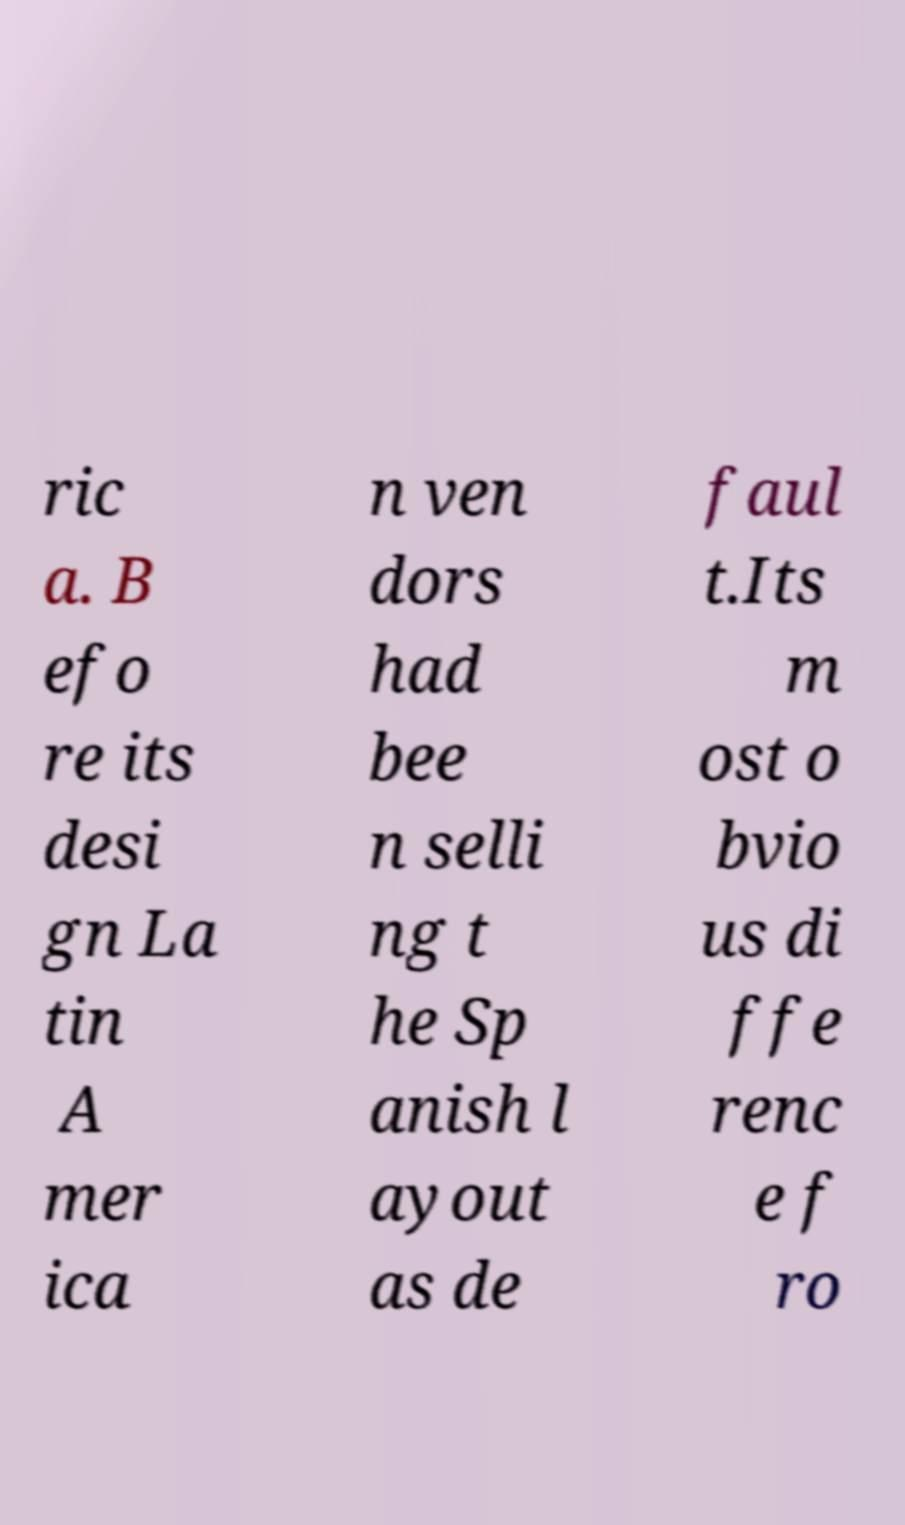There's text embedded in this image that I need extracted. Can you transcribe it verbatim? ric a. B efo re its desi gn La tin A mer ica n ven dors had bee n selli ng t he Sp anish l ayout as de faul t.Its m ost o bvio us di ffe renc e f ro 